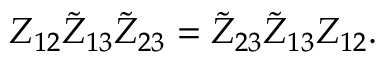Convert formula to latex. <formula><loc_0><loc_0><loc_500><loc_500>Z _ { 1 2 } \tilde { Z } _ { 1 3 } \tilde { Z } _ { 2 3 } = \tilde { Z } _ { 2 3 } \tilde { Z } _ { 1 3 } Z _ { 1 2 } .</formula> 